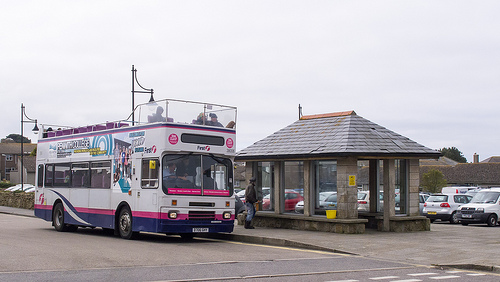Is this a bus or a train? This is a bus. 